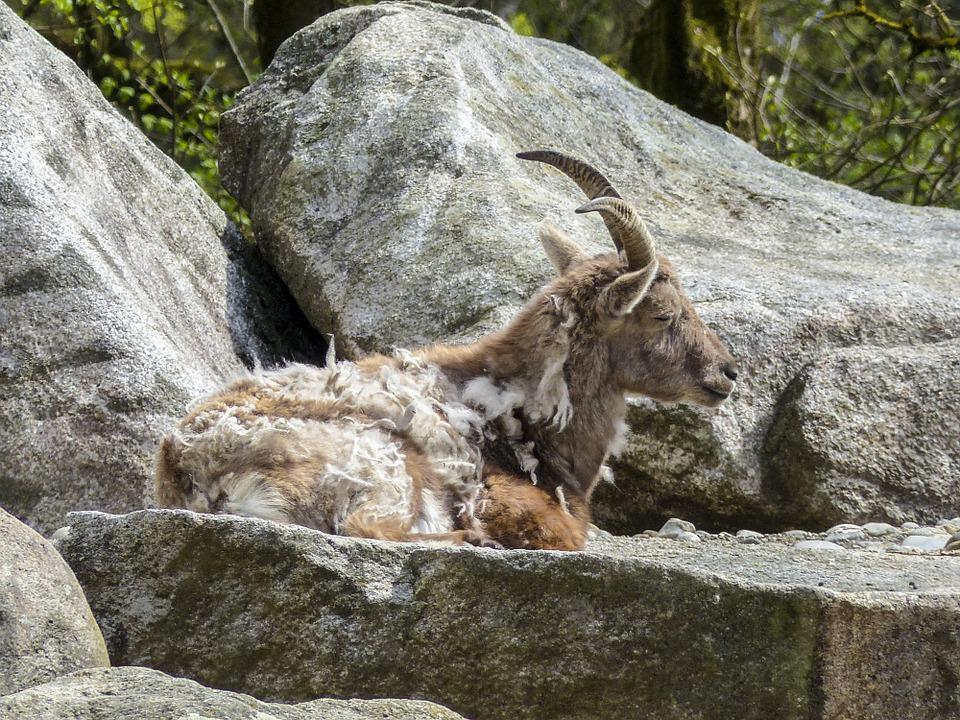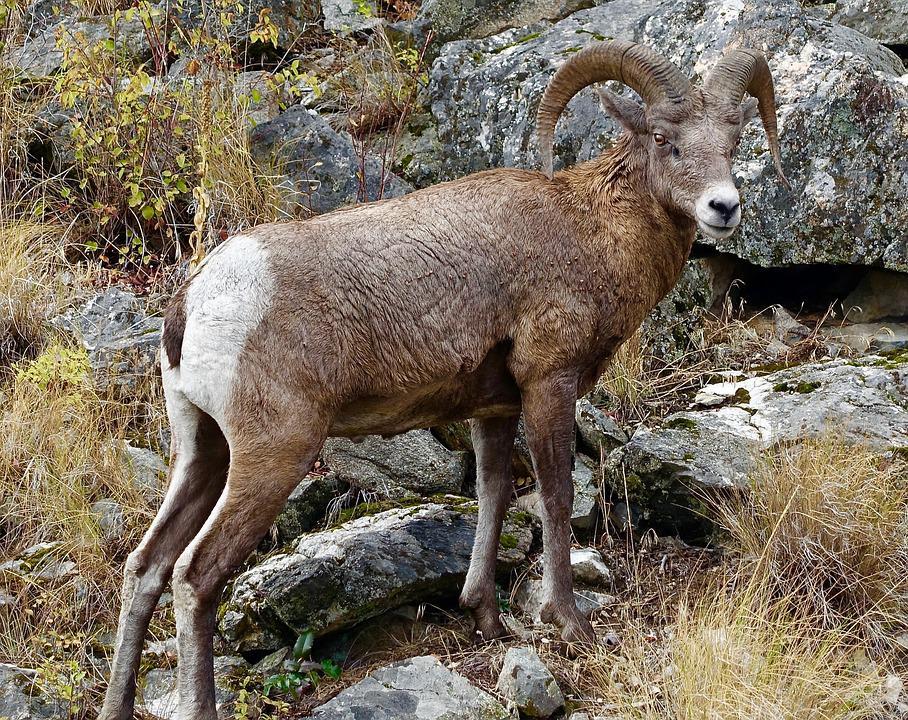The first image is the image on the left, the second image is the image on the right. For the images displayed, is the sentence "There are goats balancing on a very very steep cliffside." factually correct? Answer yes or no. No. 